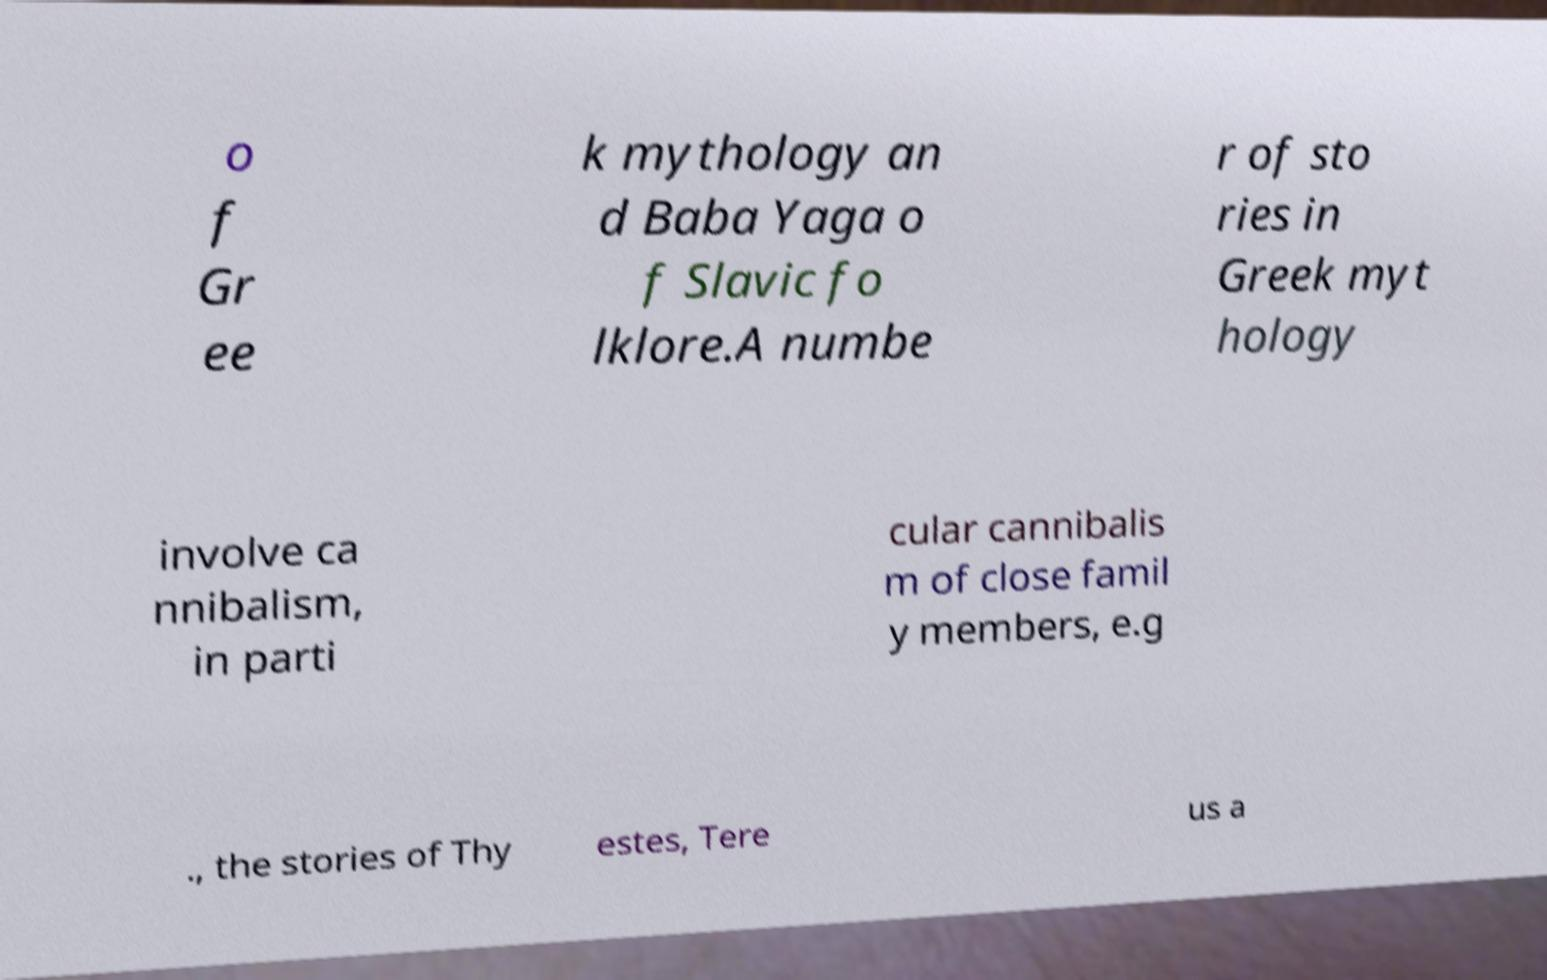Can you read and provide the text displayed in the image?This photo seems to have some interesting text. Can you extract and type it out for me? o f Gr ee k mythology an d Baba Yaga o f Slavic fo lklore.A numbe r of sto ries in Greek myt hology involve ca nnibalism, in parti cular cannibalis m of close famil y members, e.g ., the stories of Thy estes, Tere us a 